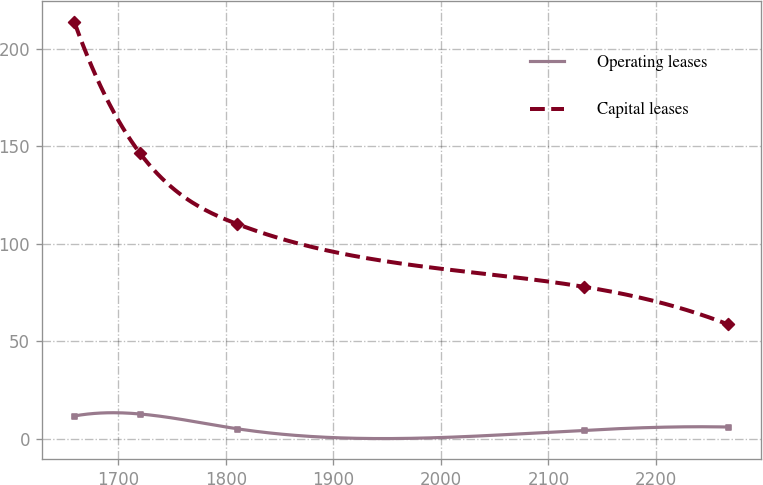Convert chart to OTSL. <chart><loc_0><loc_0><loc_500><loc_500><line_chart><ecel><fcel>Operating leases<fcel>Capital leases<nl><fcel>1659.36<fcel>11.73<fcel>213.6<nl><fcel>1720.13<fcel>12.75<fcel>146.56<nl><fcel>1810.18<fcel>5.21<fcel>110.23<nl><fcel>2133.46<fcel>4.37<fcel>77.9<nl><fcel>2267.02<fcel>6.05<fcel>58.65<nl></chart> 